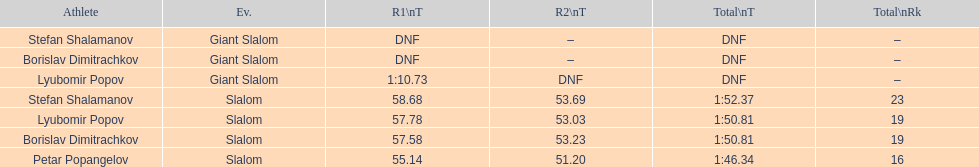Which athlete finished the first race but did not finish the second race? Lyubomir Popov. 